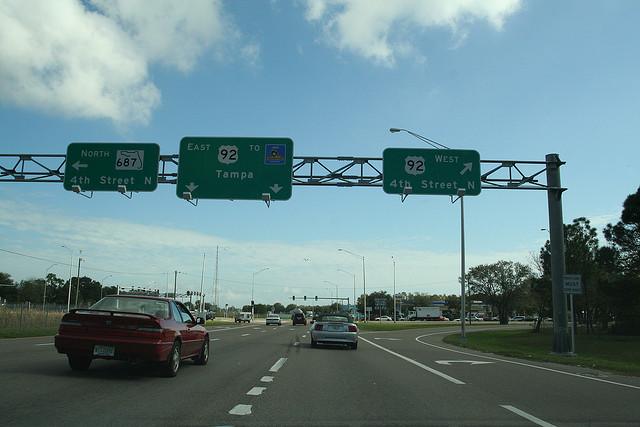What state is Tampa in?
Quick response, please. Florida. Is the sky clear?
Quick response, please. No. Are the cars in this picture parked?
Concise answer only. No. What exit is to the right?
Short answer required. 4th street. Do you go straight or turn to get to 4th Street N?
Write a very short answer. Turn. Is there a tourist attraction mentioned on the sign?
Give a very brief answer. No. 